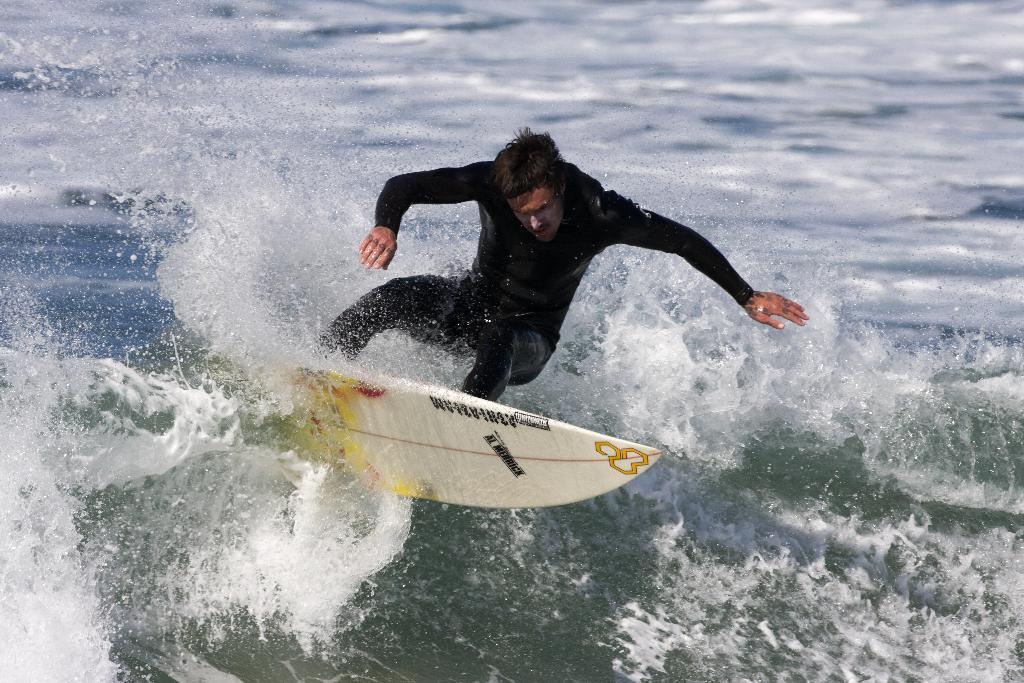Can you describe this image briefly? In this picture we can see a man is surfing with the help of surfboard and we can see water. 